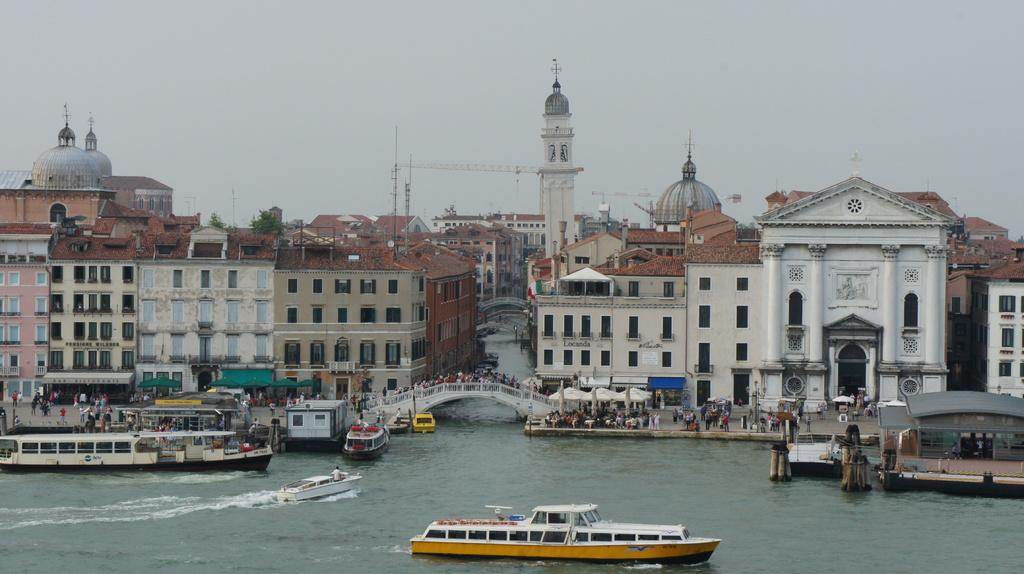What is in the water in the image? There are ships in the water in the image. What can be seen in the background of the image? There are buildings and the sky visible in the background of the image. What type of hat is being worn by the ship in the image? There are no hats present in the image, as it features ships in the water and buildings in the background. 